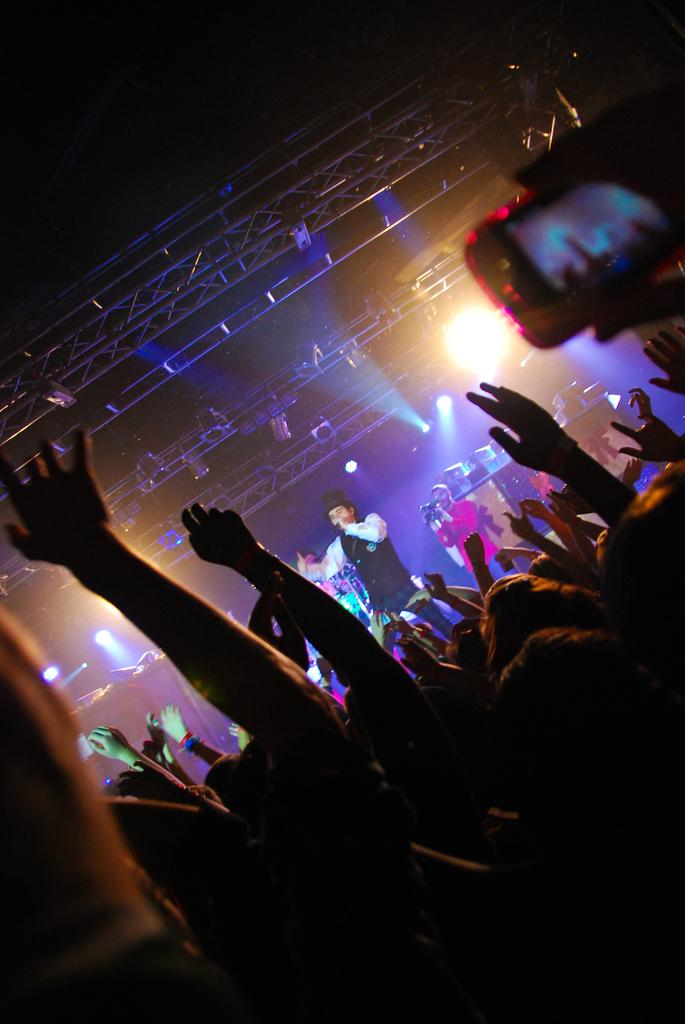What is happening in the image? There is a crowd in the image, and a person is singing on a microphone. Who might be capturing the event in the image? There is a person holding a camera in the image. What can be seen in the background of the image? There are lights visible in the background of the image. What type of competition is taking place in the image? There is no competition present in the image; it features a person singing on a microphone in front of a crowd. Can you tell me how many cubs are visible in the image? There are no cubs present in the image. 